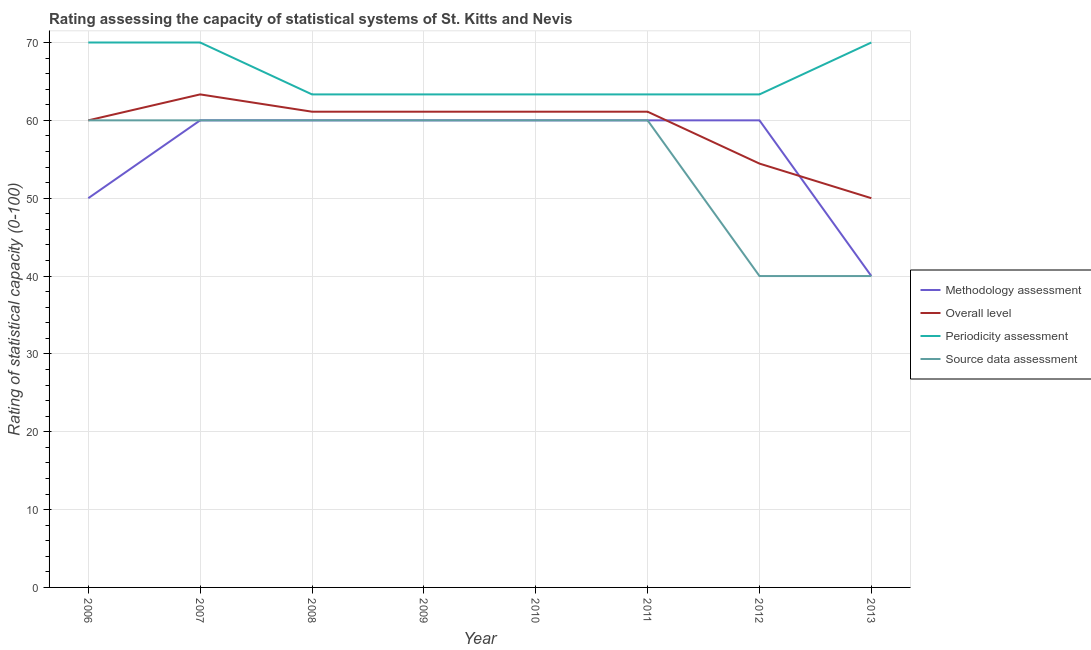Does the line corresponding to methodology assessment rating intersect with the line corresponding to periodicity assessment rating?
Offer a very short reply. No. What is the periodicity assessment rating in 2008?
Offer a terse response. 63.33. Across all years, what is the maximum source data assessment rating?
Your response must be concise. 60. Across all years, what is the minimum periodicity assessment rating?
Your response must be concise. 63.33. What is the total periodicity assessment rating in the graph?
Provide a short and direct response. 526.67. What is the difference between the periodicity assessment rating in 2010 and that in 2013?
Give a very brief answer. -6.67. What is the difference between the source data assessment rating in 2009 and the overall level rating in 2010?
Provide a short and direct response. -1.11. What is the average periodicity assessment rating per year?
Offer a very short reply. 65.83. In the year 2011, what is the difference between the source data assessment rating and overall level rating?
Give a very brief answer. -1.11. What is the ratio of the periodicity assessment rating in 2007 to that in 2011?
Your answer should be compact. 1.11. Is the overall level rating in 2010 less than that in 2011?
Provide a short and direct response. No. Is the difference between the overall level rating in 2012 and 2013 greater than the difference between the source data assessment rating in 2012 and 2013?
Your response must be concise. Yes. What is the difference between the highest and the second highest overall level rating?
Offer a very short reply. 2.22. What is the difference between the highest and the lowest methodology assessment rating?
Your answer should be compact. 20. In how many years, is the source data assessment rating greater than the average source data assessment rating taken over all years?
Provide a short and direct response. 6. Is it the case that in every year, the sum of the methodology assessment rating and source data assessment rating is greater than the sum of periodicity assessment rating and overall level rating?
Ensure brevity in your answer.  No. Does the periodicity assessment rating monotonically increase over the years?
Offer a very short reply. No. Is the methodology assessment rating strictly less than the periodicity assessment rating over the years?
Offer a very short reply. Yes. What is the difference between two consecutive major ticks on the Y-axis?
Offer a terse response. 10. Are the values on the major ticks of Y-axis written in scientific E-notation?
Ensure brevity in your answer.  No. Does the graph contain grids?
Provide a short and direct response. Yes. Where does the legend appear in the graph?
Offer a very short reply. Center right. How many legend labels are there?
Make the answer very short. 4. How are the legend labels stacked?
Your answer should be compact. Vertical. What is the title of the graph?
Provide a short and direct response. Rating assessing the capacity of statistical systems of St. Kitts and Nevis. What is the label or title of the X-axis?
Your answer should be very brief. Year. What is the label or title of the Y-axis?
Your response must be concise. Rating of statistical capacity (0-100). What is the Rating of statistical capacity (0-100) of Overall level in 2007?
Your response must be concise. 63.33. What is the Rating of statistical capacity (0-100) in Source data assessment in 2007?
Offer a very short reply. 60. What is the Rating of statistical capacity (0-100) in Methodology assessment in 2008?
Keep it short and to the point. 60. What is the Rating of statistical capacity (0-100) of Overall level in 2008?
Ensure brevity in your answer.  61.11. What is the Rating of statistical capacity (0-100) of Periodicity assessment in 2008?
Make the answer very short. 63.33. What is the Rating of statistical capacity (0-100) in Source data assessment in 2008?
Ensure brevity in your answer.  60. What is the Rating of statistical capacity (0-100) in Overall level in 2009?
Keep it short and to the point. 61.11. What is the Rating of statistical capacity (0-100) in Periodicity assessment in 2009?
Provide a short and direct response. 63.33. What is the Rating of statistical capacity (0-100) in Overall level in 2010?
Offer a very short reply. 61.11. What is the Rating of statistical capacity (0-100) of Periodicity assessment in 2010?
Provide a succinct answer. 63.33. What is the Rating of statistical capacity (0-100) in Source data assessment in 2010?
Provide a short and direct response. 60. What is the Rating of statistical capacity (0-100) of Overall level in 2011?
Ensure brevity in your answer.  61.11. What is the Rating of statistical capacity (0-100) of Periodicity assessment in 2011?
Offer a terse response. 63.33. What is the Rating of statistical capacity (0-100) in Methodology assessment in 2012?
Your response must be concise. 60. What is the Rating of statistical capacity (0-100) in Overall level in 2012?
Your answer should be compact. 54.44. What is the Rating of statistical capacity (0-100) in Periodicity assessment in 2012?
Give a very brief answer. 63.33. What is the Rating of statistical capacity (0-100) of Source data assessment in 2013?
Ensure brevity in your answer.  40. Across all years, what is the maximum Rating of statistical capacity (0-100) of Methodology assessment?
Make the answer very short. 60. Across all years, what is the maximum Rating of statistical capacity (0-100) in Overall level?
Your response must be concise. 63.33. Across all years, what is the minimum Rating of statistical capacity (0-100) in Methodology assessment?
Provide a short and direct response. 40. Across all years, what is the minimum Rating of statistical capacity (0-100) of Periodicity assessment?
Provide a succinct answer. 63.33. Across all years, what is the minimum Rating of statistical capacity (0-100) in Source data assessment?
Provide a succinct answer. 40. What is the total Rating of statistical capacity (0-100) of Methodology assessment in the graph?
Provide a short and direct response. 450. What is the total Rating of statistical capacity (0-100) in Overall level in the graph?
Keep it short and to the point. 472.22. What is the total Rating of statistical capacity (0-100) of Periodicity assessment in the graph?
Offer a very short reply. 526.67. What is the total Rating of statistical capacity (0-100) of Source data assessment in the graph?
Provide a short and direct response. 440. What is the difference between the Rating of statistical capacity (0-100) in Overall level in 2006 and that in 2007?
Provide a short and direct response. -3.33. What is the difference between the Rating of statistical capacity (0-100) of Source data assessment in 2006 and that in 2007?
Provide a short and direct response. 0. What is the difference between the Rating of statistical capacity (0-100) in Methodology assessment in 2006 and that in 2008?
Provide a short and direct response. -10. What is the difference between the Rating of statistical capacity (0-100) of Overall level in 2006 and that in 2008?
Keep it short and to the point. -1.11. What is the difference between the Rating of statistical capacity (0-100) in Periodicity assessment in 2006 and that in 2008?
Keep it short and to the point. 6.67. What is the difference between the Rating of statistical capacity (0-100) in Overall level in 2006 and that in 2009?
Ensure brevity in your answer.  -1.11. What is the difference between the Rating of statistical capacity (0-100) of Methodology assessment in 2006 and that in 2010?
Provide a short and direct response. -10. What is the difference between the Rating of statistical capacity (0-100) of Overall level in 2006 and that in 2010?
Your answer should be compact. -1.11. What is the difference between the Rating of statistical capacity (0-100) in Periodicity assessment in 2006 and that in 2010?
Provide a short and direct response. 6.67. What is the difference between the Rating of statistical capacity (0-100) in Source data assessment in 2006 and that in 2010?
Give a very brief answer. 0. What is the difference between the Rating of statistical capacity (0-100) of Methodology assessment in 2006 and that in 2011?
Make the answer very short. -10. What is the difference between the Rating of statistical capacity (0-100) of Overall level in 2006 and that in 2011?
Your answer should be compact. -1.11. What is the difference between the Rating of statistical capacity (0-100) of Periodicity assessment in 2006 and that in 2011?
Keep it short and to the point. 6.67. What is the difference between the Rating of statistical capacity (0-100) in Source data assessment in 2006 and that in 2011?
Your answer should be compact. 0. What is the difference between the Rating of statistical capacity (0-100) of Methodology assessment in 2006 and that in 2012?
Your response must be concise. -10. What is the difference between the Rating of statistical capacity (0-100) in Overall level in 2006 and that in 2012?
Offer a very short reply. 5.56. What is the difference between the Rating of statistical capacity (0-100) of Periodicity assessment in 2006 and that in 2012?
Your answer should be compact. 6.67. What is the difference between the Rating of statistical capacity (0-100) of Overall level in 2006 and that in 2013?
Make the answer very short. 10. What is the difference between the Rating of statistical capacity (0-100) of Source data assessment in 2006 and that in 2013?
Make the answer very short. 20. What is the difference between the Rating of statistical capacity (0-100) in Overall level in 2007 and that in 2008?
Offer a very short reply. 2.22. What is the difference between the Rating of statistical capacity (0-100) in Periodicity assessment in 2007 and that in 2008?
Your answer should be very brief. 6.67. What is the difference between the Rating of statistical capacity (0-100) of Source data assessment in 2007 and that in 2008?
Ensure brevity in your answer.  0. What is the difference between the Rating of statistical capacity (0-100) of Methodology assessment in 2007 and that in 2009?
Your answer should be compact. 0. What is the difference between the Rating of statistical capacity (0-100) of Overall level in 2007 and that in 2009?
Keep it short and to the point. 2.22. What is the difference between the Rating of statistical capacity (0-100) of Source data assessment in 2007 and that in 2009?
Your answer should be compact. 0. What is the difference between the Rating of statistical capacity (0-100) in Overall level in 2007 and that in 2010?
Your answer should be compact. 2.22. What is the difference between the Rating of statistical capacity (0-100) of Periodicity assessment in 2007 and that in 2010?
Offer a very short reply. 6.67. What is the difference between the Rating of statistical capacity (0-100) of Source data assessment in 2007 and that in 2010?
Your answer should be very brief. 0. What is the difference between the Rating of statistical capacity (0-100) of Overall level in 2007 and that in 2011?
Keep it short and to the point. 2.22. What is the difference between the Rating of statistical capacity (0-100) in Periodicity assessment in 2007 and that in 2011?
Offer a very short reply. 6.67. What is the difference between the Rating of statistical capacity (0-100) of Overall level in 2007 and that in 2012?
Offer a terse response. 8.89. What is the difference between the Rating of statistical capacity (0-100) in Methodology assessment in 2007 and that in 2013?
Provide a succinct answer. 20. What is the difference between the Rating of statistical capacity (0-100) of Overall level in 2007 and that in 2013?
Offer a very short reply. 13.33. What is the difference between the Rating of statistical capacity (0-100) in Periodicity assessment in 2007 and that in 2013?
Provide a short and direct response. 0. What is the difference between the Rating of statistical capacity (0-100) of Source data assessment in 2007 and that in 2013?
Make the answer very short. 20. What is the difference between the Rating of statistical capacity (0-100) in Methodology assessment in 2008 and that in 2009?
Your answer should be compact. 0. What is the difference between the Rating of statistical capacity (0-100) of Overall level in 2008 and that in 2009?
Make the answer very short. 0. What is the difference between the Rating of statistical capacity (0-100) of Source data assessment in 2008 and that in 2009?
Your answer should be very brief. 0. What is the difference between the Rating of statistical capacity (0-100) of Methodology assessment in 2008 and that in 2010?
Your answer should be very brief. 0. What is the difference between the Rating of statistical capacity (0-100) in Overall level in 2008 and that in 2010?
Your answer should be compact. 0. What is the difference between the Rating of statistical capacity (0-100) of Periodicity assessment in 2008 and that in 2010?
Provide a succinct answer. 0. What is the difference between the Rating of statistical capacity (0-100) in Overall level in 2008 and that in 2011?
Make the answer very short. 0. What is the difference between the Rating of statistical capacity (0-100) in Periodicity assessment in 2008 and that in 2011?
Give a very brief answer. 0. What is the difference between the Rating of statistical capacity (0-100) in Methodology assessment in 2008 and that in 2012?
Give a very brief answer. 0. What is the difference between the Rating of statistical capacity (0-100) of Overall level in 2008 and that in 2012?
Offer a very short reply. 6.67. What is the difference between the Rating of statistical capacity (0-100) in Periodicity assessment in 2008 and that in 2012?
Your answer should be compact. 0. What is the difference between the Rating of statistical capacity (0-100) of Source data assessment in 2008 and that in 2012?
Your answer should be very brief. 20. What is the difference between the Rating of statistical capacity (0-100) of Overall level in 2008 and that in 2013?
Your answer should be very brief. 11.11. What is the difference between the Rating of statistical capacity (0-100) in Periodicity assessment in 2008 and that in 2013?
Provide a succinct answer. -6.67. What is the difference between the Rating of statistical capacity (0-100) of Methodology assessment in 2009 and that in 2010?
Provide a succinct answer. 0. What is the difference between the Rating of statistical capacity (0-100) of Overall level in 2009 and that in 2010?
Keep it short and to the point. 0. What is the difference between the Rating of statistical capacity (0-100) of Periodicity assessment in 2009 and that in 2010?
Offer a terse response. 0. What is the difference between the Rating of statistical capacity (0-100) in Source data assessment in 2009 and that in 2010?
Ensure brevity in your answer.  0. What is the difference between the Rating of statistical capacity (0-100) of Methodology assessment in 2009 and that in 2011?
Give a very brief answer. 0. What is the difference between the Rating of statistical capacity (0-100) of Overall level in 2009 and that in 2011?
Offer a very short reply. 0. What is the difference between the Rating of statistical capacity (0-100) in Methodology assessment in 2009 and that in 2013?
Offer a very short reply. 20. What is the difference between the Rating of statistical capacity (0-100) of Overall level in 2009 and that in 2013?
Offer a very short reply. 11.11. What is the difference between the Rating of statistical capacity (0-100) of Periodicity assessment in 2009 and that in 2013?
Make the answer very short. -6.67. What is the difference between the Rating of statistical capacity (0-100) in Source data assessment in 2010 and that in 2011?
Keep it short and to the point. 0. What is the difference between the Rating of statistical capacity (0-100) of Overall level in 2010 and that in 2013?
Provide a short and direct response. 11.11. What is the difference between the Rating of statistical capacity (0-100) in Periodicity assessment in 2010 and that in 2013?
Keep it short and to the point. -6.67. What is the difference between the Rating of statistical capacity (0-100) in Source data assessment in 2010 and that in 2013?
Your response must be concise. 20. What is the difference between the Rating of statistical capacity (0-100) of Overall level in 2011 and that in 2012?
Give a very brief answer. 6.67. What is the difference between the Rating of statistical capacity (0-100) of Periodicity assessment in 2011 and that in 2012?
Make the answer very short. 0. What is the difference between the Rating of statistical capacity (0-100) of Methodology assessment in 2011 and that in 2013?
Your answer should be very brief. 20. What is the difference between the Rating of statistical capacity (0-100) of Overall level in 2011 and that in 2013?
Provide a succinct answer. 11.11. What is the difference between the Rating of statistical capacity (0-100) in Periodicity assessment in 2011 and that in 2013?
Your answer should be compact. -6.67. What is the difference between the Rating of statistical capacity (0-100) in Source data assessment in 2011 and that in 2013?
Your answer should be compact. 20. What is the difference between the Rating of statistical capacity (0-100) of Overall level in 2012 and that in 2013?
Keep it short and to the point. 4.44. What is the difference between the Rating of statistical capacity (0-100) in Periodicity assessment in 2012 and that in 2013?
Offer a very short reply. -6.67. What is the difference between the Rating of statistical capacity (0-100) of Methodology assessment in 2006 and the Rating of statistical capacity (0-100) of Overall level in 2007?
Your response must be concise. -13.33. What is the difference between the Rating of statistical capacity (0-100) of Methodology assessment in 2006 and the Rating of statistical capacity (0-100) of Periodicity assessment in 2007?
Make the answer very short. -20. What is the difference between the Rating of statistical capacity (0-100) of Methodology assessment in 2006 and the Rating of statistical capacity (0-100) of Source data assessment in 2007?
Offer a very short reply. -10. What is the difference between the Rating of statistical capacity (0-100) in Methodology assessment in 2006 and the Rating of statistical capacity (0-100) in Overall level in 2008?
Offer a terse response. -11.11. What is the difference between the Rating of statistical capacity (0-100) of Methodology assessment in 2006 and the Rating of statistical capacity (0-100) of Periodicity assessment in 2008?
Give a very brief answer. -13.33. What is the difference between the Rating of statistical capacity (0-100) in Methodology assessment in 2006 and the Rating of statistical capacity (0-100) in Source data assessment in 2008?
Give a very brief answer. -10. What is the difference between the Rating of statistical capacity (0-100) in Overall level in 2006 and the Rating of statistical capacity (0-100) in Source data assessment in 2008?
Offer a very short reply. 0. What is the difference between the Rating of statistical capacity (0-100) of Periodicity assessment in 2006 and the Rating of statistical capacity (0-100) of Source data assessment in 2008?
Ensure brevity in your answer.  10. What is the difference between the Rating of statistical capacity (0-100) of Methodology assessment in 2006 and the Rating of statistical capacity (0-100) of Overall level in 2009?
Your answer should be compact. -11.11. What is the difference between the Rating of statistical capacity (0-100) of Methodology assessment in 2006 and the Rating of statistical capacity (0-100) of Periodicity assessment in 2009?
Provide a succinct answer. -13.33. What is the difference between the Rating of statistical capacity (0-100) in Periodicity assessment in 2006 and the Rating of statistical capacity (0-100) in Source data assessment in 2009?
Offer a terse response. 10. What is the difference between the Rating of statistical capacity (0-100) in Methodology assessment in 2006 and the Rating of statistical capacity (0-100) in Overall level in 2010?
Ensure brevity in your answer.  -11.11. What is the difference between the Rating of statistical capacity (0-100) of Methodology assessment in 2006 and the Rating of statistical capacity (0-100) of Periodicity assessment in 2010?
Ensure brevity in your answer.  -13.33. What is the difference between the Rating of statistical capacity (0-100) in Methodology assessment in 2006 and the Rating of statistical capacity (0-100) in Source data assessment in 2010?
Provide a short and direct response. -10. What is the difference between the Rating of statistical capacity (0-100) in Overall level in 2006 and the Rating of statistical capacity (0-100) in Periodicity assessment in 2010?
Ensure brevity in your answer.  -3.33. What is the difference between the Rating of statistical capacity (0-100) in Overall level in 2006 and the Rating of statistical capacity (0-100) in Source data assessment in 2010?
Provide a succinct answer. 0. What is the difference between the Rating of statistical capacity (0-100) in Periodicity assessment in 2006 and the Rating of statistical capacity (0-100) in Source data assessment in 2010?
Ensure brevity in your answer.  10. What is the difference between the Rating of statistical capacity (0-100) of Methodology assessment in 2006 and the Rating of statistical capacity (0-100) of Overall level in 2011?
Your answer should be compact. -11.11. What is the difference between the Rating of statistical capacity (0-100) in Methodology assessment in 2006 and the Rating of statistical capacity (0-100) in Periodicity assessment in 2011?
Provide a short and direct response. -13.33. What is the difference between the Rating of statistical capacity (0-100) in Methodology assessment in 2006 and the Rating of statistical capacity (0-100) in Source data assessment in 2011?
Offer a terse response. -10. What is the difference between the Rating of statistical capacity (0-100) in Overall level in 2006 and the Rating of statistical capacity (0-100) in Periodicity assessment in 2011?
Give a very brief answer. -3.33. What is the difference between the Rating of statistical capacity (0-100) in Periodicity assessment in 2006 and the Rating of statistical capacity (0-100) in Source data assessment in 2011?
Ensure brevity in your answer.  10. What is the difference between the Rating of statistical capacity (0-100) in Methodology assessment in 2006 and the Rating of statistical capacity (0-100) in Overall level in 2012?
Your response must be concise. -4.44. What is the difference between the Rating of statistical capacity (0-100) in Methodology assessment in 2006 and the Rating of statistical capacity (0-100) in Periodicity assessment in 2012?
Your answer should be compact. -13.33. What is the difference between the Rating of statistical capacity (0-100) of Overall level in 2006 and the Rating of statistical capacity (0-100) of Source data assessment in 2012?
Offer a terse response. 20. What is the difference between the Rating of statistical capacity (0-100) of Methodology assessment in 2006 and the Rating of statistical capacity (0-100) of Overall level in 2013?
Keep it short and to the point. 0. What is the difference between the Rating of statistical capacity (0-100) in Methodology assessment in 2006 and the Rating of statistical capacity (0-100) in Periodicity assessment in 2013?
Provide a short and direct response. -20. What is the difference between the Rating of statistical capacity (0-100) in Methodology assessment in 2006 and the Rating of statistical capacity (0-100) in Source data assessment in 2013?
Keep it short and to the point. 10. What is the difference between the Rating of statistical capacity (0-100) in Overall level in 2006 and the Rating of statistical capacity (0-100) in Source data assessment in 2013?
Make the answer very short. 20. What is the difference between the Rating of statistical capacity (0-100) in Methodology assessment in 2007 and the Rating of statistical capacity (0-100) in Overall level in 2008?
Keep it short and to the point. -1.11. What is the difference between the Rating of statistical capacity (0-100) in Overall level in 2007 and the Rating of statistical capacity (0-100) in Periodicity assessment in 2008?
Offer a terse response. 0. What is the difference between the Rating of statistical capacity (0-100) in Periodicity assessment in 2007 and the Rating of statistical capacity (0-100) in Source data assessment in 2008?
Your answer should be very brief. 10. What is the difference between the Rating of statistical capacity (0-100) of Methodology assessment in 2007 and the Rating of statistical capacity (0-100) of Overall level in 2009?
Offer a very short reply. -1.11. What is the difference between the Rating of statistical capacity (0-100) in Methodology assessment in 2007 and the Rating of statistical capacity (0-100) in Periodicity assessment in 2009?
Provide a short and direct response. -3.33. What is the difference between the Rating of statistical capacity (0-100) of Methodology assessment in 2007 and the Rating of statistical capacity (0-100) of Source data assessment in 2009?
Offer a very short reply. 0. What is the difference between the Rating of statistical capacity (0-100) of Methodology assessment in 2007 and the Rating of statistical capacity (0-100) of Overall level in 2010?
Offer a terse response. -1.11. What is the difference between the Rating of statistical capacity (0-100) of Methodology assessment in 2007 and the Rating of statistical capacity (0-100) of Overall level in 2011?
Offer a terse response. -1.11. What is the difference between the Rating of statistical capacity (0-100) of Methodology assessment in 2007 and the Rating of statistical capacity (0-100) of Periodicity assessment in 2011?
Keep it short and to the point. -3.33. What is the difference between the Rating of statistical capacity (0-100) of Methodology assessment in 2007 and the Rating of statistical capacity (0-100) of Source data assessment in 2011?
Offer a very short reply. 0. What is the difference between the Rating of statistical capacity (0-100) in Overall level in 2007 and the Rating of statistical capacity (0-100) in Periodicity assessment in 2011?
Provide a succinct answer. 0. What is the difference between the Rating of statistical capacity (0-100) in Methodology assessment in 2007 and the Rating of statistical capacity (0-100) in Overall level in 2012?
Offer a terse response. 5.56. What is the difference between the Rating of statistical capacity (0-100) in Methodology assessment in 2007 and the Rating of statistical capacity (0-100) in Periodicity assessment in 2012?
Provide a succinct answer. -3.33. What is the difference between the Rating of statistical capacity (0-100) of Methodology assessment in 2007 and the Rating of statistical capacity (0-100) of Source data assessment in 2012?
Give a very brief answer. 20. What is the difference between the Rating of statistical capacity (0-100) of Overall level in 2007 and the Rating of statistical capacity (0-100) of Source data assessment in 2012?
Your response must be concise. 23.33. What is the difference between the Rating of statistical capacity (0-100) of Methodology assessment in 2007 and the Rating of statistical capacity (0-100) of Periodicity assessment in 2013?
Provide a short and direct response. -10. What is the difference between the Rating of statistical capacity (0-100) of Methodology assessment in 2007 and the Rating of statistical capacity (0-100) of Source data assessment in 2013?
Make the answer very short. 20. What is the difference between the Rating of statistical capacity (0-100) in Overall level in 2007 and the Rating of statistical capacity (0-100) in Periodicity assessment in 2013?
Provide a short and direct response. -6.67. What is the difference between the Rating of statistical capacity (0-100) in Overall level in 2007 and the Rating of statistical capacity (0-100) in Source data assessment in 2013?
Offer a terse response. 23.33. What is the difference between the Rating of statistical capacity (0-100) of Methodology assessment in 2008 and the Rating of statistical capacity (0-100) of Overall level in 2009?
Offer a very short reply. -1.11. What is the difference between the Rating of statistical capacity (0-100) of Overall level in 2008 and the Rating of statistical capacity (0-100) of Periodicity assessment in 2009?
Provide a short and direct response. -2.22. What is the difference between the Rating of statistical capacity (0-100) in Periodicity assessment in 2008 and the Rating of statistical capacity (0-100) in Source data assessment in 2009?
Offer a very short reply. 3.33. What is the difference between the Rating of statistical capacity (0-100) in Methodology assessment in 2008 and the Rating of statistical capacity (0-100) in Overall level in 2010?
Keep it short and to the point. -1.11. What is the difference between the Rating of statistical capacity (0-100) of Overall level in 2008 and the Rating of statistical capacity (0-100) of Periodicity assessment in 2010?
Your answer should be very brief. -2.22. What is the difference between the Rating of statistical capacity (0-100) in Overall level in 2008 and the Rating of statistical capacity (0-100) in Source data assessment in 2010?
Provide a succinct answer. 1.11. What is the difference between the Rating of statistical capacity (0-100) of Periodicity assessment in 2008 and the Rating of statistical capacity (0-100) of Source data assessment in 2010?
Your answer should be very brief. 3.33. What is the difference between the Rating of statistical capacity (0-100) in Methodology assessment in 2008 and the Rating of statistical capacity (0-100) in Overall level in 2011?
Provide a short and direct response. -1.11. What is the difference between the Rating of statistical capacity (0-100) of Methodology assessment in 2008 and the Rating of statistical capacity (0-100) of Periodicity assessment in 2011?
Offer a terse response. -3.33. What is the difference between the Rating of statistical capacity (0-100) of Overall level in 2008 and the Rating of statistical capacity (0-100) of Periodicity assessment in 2011?
Offer a terse response. -2.22. What is the difference between the Rating of statistical capacity (0-100) in Overall level in 2008 and the Rating of statistical capacity (0-100) in Source data assessment in 2011?
Provide a short and direct response. 1.11. What is the difference between the Rating of statistical capacity (0-100) of Methodology assessment in 2008 and the Rating of statistical capacity (0-100) of Overall level in 2012?
Provide a short and direct response. 5.56. What is the difference between the Rating of statistical capacity (0-100) in Methodology assessment in 2008 and the Rating of statistical capacity (0-100) in Source data assessment in 2012?
Your response must be concise. 20. What is the difference between the Rating of statistical capacity (0-100) of Overall level in 2008 and the Rating of statistical capacity (0-100) of Periodicity assessment in 2012?
Provide a succinct answer. -2.22. What is the difference between the Rating of statistical capacity (0-100) in Overall level in 2008 and the Rating of statistical capacity (0-100) in Source data assessment in 2012?
Offer a terse response. 21.11. What is the difference between the Rating of statistical capacity (0-100) of Periodicity assessment in 2008 and the Rating of statistical capacity (0-100) of Source data assessment in 2012?
Provide a short and direct response. 23.33. What is the difference between the Rating of statistical capacity (0-100) in Overall level in 2008 and the Rating of statistical capacity (0-100) in Periodicity assessment in 2013?
Provide a succinct answer. -8.89. What is the difference between the Rating of statistical capacity (0-100) of Overall level in 2008 and the Rating of statistical capacity (0-100) of Source data assessment in 2013?
Keep it short and to the point. 21.11. What is the difference between the Rating of statistical capacity (0-100) in Periodicity assessment in 2008 and the Rating of statistical capacity (0-100) in Source data assessment in 2013?
Offer a very short reply. 23.33. What is the difference between the Rating of statistical capacity (0-100) in Methodology assessment in 2009 and the Rating of statistical capacity (0-100) in Overall level in 2010?
Ensure brevity in your answer.  -1.11. What is the difference between the Rating of statistical capacity (0-100) in Overall level in 2009 and the Rating of statistical capacity (0-100) in Periodicity assessment in 2010?
Keep it short and to the point. -2.22. What is the difference between the Rating of statistical capacity (0-100) in Overall level in 2009 and the Rating of statistical capacity (0-100) in Source data assessment in 2010?
Your response must be concise. 1.11. What is the difference between the Rating of statistical capacity (0-100) in Periodicity assessment in 2009 and the Rating of statistical capacity (0-100) in Source data assessment in 2010?
Offer a very short reply. 3.33. What is the difference between the Rating of statistical capacity (0-100) of Methodology assessment in 2009 and the Rating of statistical capacity (0-100) of Overall level in 2011?
Ensure brevity in your answer.  -1.11. What is the difference between the Rating of statistical capacity (0-100) in Overall level in 2009 and the Rating of statistical capacity (0-100) in Periodicity assessment in 2011?
Keep it short and to the point. -2.22. What is the difference between the Rating of statistical capacity (0-100) of Methodology assessment in 2009 and the Rating of statistical capacity (0-100) of Overall level in 2012?
Offer a terse response. 5.56. What is the difference between the Rating of statistical capacity (0-100) in Methodology assessment in 2009 and the Rating of statistical capacity (0-100) in Periodicity assessment in 2012?
Ensure brevity in your answer.  -3.33. What is the difference between the Rating of statistical capacity (0-100) in Methodology assessment in 2009 and the Rating of statistical capacity (0-100) in Source data assessment in 2012?
Your answer should be compact. 20. What is the difference between the Rating of statistical capacity (0-100) of Overall level in 2009 and the Rating of statistical capacity (0-100) of Periodicity assessment in 2012?
Offer a terse response. -2.22. What is the difference between the Rating of statistical capacity (0-100) of Overall level in 2009 and the Rating of statistical capacity (0-100) of Source data assessment in 2012?
Keep it short and to the point. 21.11. What is the difference between the Rating of statistical capacity (0-100) in Periodicity assessment in 2009 and the Rating of statistical capacity (0-100) in Source data assessment in 2012?
Offer a very short reply. 23.33. What is the difference between the Rating of statistical capacity (0-100) of Methodology assessment in 2009 and the Rating of statistical capacity (0-100) of Overall level in 2013?
Your answer should be very brief. 10. What is the difference between the Rating of statistical capacity (0-100) in Methodology assessment in 2009 and the Rating of statistical capacity (0-100) in Source data assessment in 2013?
Make the answer very short. 20. What is the difference between the Rating of statistical capacity (0-100) in Overall level in 2009 and the Rating of statistical capacity (0-100) in Periodicity assessment in 2013?
Provide a succinct answer. -8.89. What is the difference between the Rating of statistical capacity (0-100) of Overall level in 2009 and the Rating of statistical capacity (0-100) of Source data assessment in 2013?
Provide a short and direct response. 21.11. What is the difference between the Rating of statistical capacity (0-100) in Periodicity assessment in 2009 and the Rating of statistical capacity (0-100) in Source data assessment in 2013?
Make the answer very short. 23.33. What is the difference between the Rating of statistical capacity (0-100) of Methodology assessment in 2010 and the Rating of statistical capacity (0-100) of Overall level in 2011?
Offer a terse response. -1.11. What is the difference between the Rating of statistical capacity (0-100) of Methodology assessment in 2010 and the Rating of statistical capacity (0-100) of Periodicity assessment in 2011?
Provide a succinct answer. -3.33. What is the difference between the Rating of statistical capacity (0-100) in Overall level in 2010 and the Rating of statistical capacity (0-100) in Periodicity assessment in 2011?
Make the answer very short. -2.22. What is the difference between the Rating of statistical capacity (0-100) of Periodicity assessment in 2010 and the Rating of statistical capacity (0-100) of Source data assessment in 2011?
Offer a very short reply. 3.33. What is the difference between the Rating of statistical capacity (0-100) in Methodology assessment in 2010 and the Rating of statistical capacity (0-100) in Overall level in 2012?
Your answer should be very brief. 5.56. What is the difference between the Rating of statistical capacity (0-100) of Methodology assessment in 2010 and the Rating of statistical capacity (0-100) of Source data assessment in 2012?
Offer a terse response. 20. What is the difference between the Rating of statistical capacity (0-100) of Overall level in 2010 and the Rating of statistical capacity (0-100) of Periodicity assessment in 2012?
Provide a short and direct response. -2.22. What is the difference between the Rating of statistical capacity (0-100) in Overall level in 2010 and the Rating of statistical capacity (0-100) in Source data assessment in 2012?
Your answer should be very brief. 21.11. What is the difference between the Rating of statistical capacity (0-100) of Periodicity assessment in 2010 and the Rating of statistical capacity (0-100) of Source data assessment in 2012?
Keep it short and to the point. 23.33. What is the difference between the Rating of statistical capacity (0-100) of Methodology assessment in 2010 and the Rating of statistical capacity (0-100) of Periodicity assessment in 2013?
Provide a short and direct response. -10. What is the difference between the Rating of statistical capacity (0-100) in Overall level in 2010 and the Rating of statistical capacity (0-100) in Periodicity assessment in 2013?
Your answer should be very brief. -8.89. What is the difference between the Rating of statistical capacity (0-100) of Overall level in 2010 and the Rating of statistical capacity (0-100) of Source data assessment in 2013?
Offer a very short reply. 21.11. What is the difference between the Rating of statistical capacity (0-100) in Periodicity assessment in 2010 and the Rating of statistical capacity (0-100) in Source data assessment in 2013?
Ensure brevity in your answer.  23.33. What is the difference between the Rating of statistical capacity (0-100) in Methodology assessment in 2011 and the Rating of statistical capacity (0-100) in Overall level in 2012?
Your answer should be compact. 5.56. What is the difference between the Rating of statistical capacity (0-100) of Methodology assessment in 2011 and the Rating of statistical capacity (0-100) of Periodicity assessment in 2012?
Ensure brevity in your answer.  -3.33. What is the difference between the Rating of statistical capacity (0-100) of Overall level in 2011 and the Rating of statistical capacity (0-100) of Periodicity assessment in 2012?
Offer a terse response. -2.22. What is the difference between the Rating of statistical capacity (0-100) of Overall level in 2011 and the Rating of statistical capacity (0-100) of Source data assessment in 2012?
Your response must be concise. 21.11. What is the difference between the Rating of statistical capacity (0-100) of Periodicity assessment in 2011 and the Rating of statistical capacity (0-100) of Source data assessment in 2012?
Keep it short and to the point. 23.33. What is the difference between the Rating of statistical capacity (0-100) of Overall level in 2011 and the Rating of statistical capacity (0-100) of Periodicity assessment in 2013?
Your answer should be very brief. -8.89. What is the difference between the Rating of statistical capacity (0-100) of Overall level in 2011 and the Rating of statistical capacity (0-100) of Source data assessment in 2013?
Give a very brief answer. 21.11. What is the difference between the Rating of statistical capacity (0-100) of Periodicity assessment in 2011 and the Rating of statistical capacity (0-100) of Source data assessment in 2013?
Offer a terse response. 23.33. What is the difference between the Rating of statistical capacity (0-100) of Methodology assessment in 2012 and the Rating of statistical capacity (0-100) of Overall level in 2013?
Offer a terse response. 10. What is the difference between the Rating of statistical capacity (0-100) of Methodology assessment in 2012 and the Rating of statistical capacity (0-100) of Source data assessment in 2013?
Keep it short and to the point. 20. What is the difference between the Rating of statistical capacity (0-100) in Overall level in 2012 and the Rating of statistical capacity (0-100) in Periodicity assessment in 2013?
Your response must be concise. -15.56. What is the difference between the Rating of statistical capacity (0-100) of Overall level in 2012 and the Rating of statistical capacity (0-100) of Source data assessment in 2013?
Keep it short and to the point. 14.44. What is the difference between the Rating of statistical capacity (0-100) of Periodicity assessment in 2012 and the Rating of statistical capacity (0-100) of Source data assessment in 2013?
Make the answer very short. 23.33. What is the average Rating of statistical capacity (0-100) in Methodology assessment per year?
Your answer should be very brief. 56.25. What is the average Rating of statistical capacity (0-100) in Overall level per year?
Offer a very short reply. 59.03. What is the average Rating of statistical capacity (0-100) in Periodicity assessment per year?
Make the answer very short. 65.83. What is the average Rating of statistical capacity (0-100) in Source data assessment per year?
Make the answer very short. 55. In the year 2006, what is the difference between the Rating of statistical capacity (0-100) in Methodology assessment and Rating of statistical capacity (0-100) in Overall level?
Provide a short and direct response. -10. In the year 2006, what is the difference between the Rating of statistical capacity (0-100) in Overall level and Rating of statistical capacity (0-100) in Periodicity assessment?
Ensure brevity in your answer.  -10. In the year 2006, what is the difference between the Rating of statistical capacity (0-100) in Overall level and Rating of statistical capacity (0-100) in Source data assessment?
Provide a short and direct response. 0. In the year 2007, what is the difference between the Rating of statistical capacity (0-100) of Methodology assessment and Rating of statistical capacity (0-100) of Overall level?
Make the answer very short. -3.33. In the year 2007, what is the difference between the Rating of statistical capacity (0-100) of Overall level and Rating of statistical capacity (0-100) of Periodicity assessment?
Make the answer very short. -6.67. In the year 2008, what is the difference between the Rating of statistical capacity (0-100) in Methodology assessment and Rating of statistical capacity (0-100) in Overall level?
Keep it short and to the point. -1.11. In the year 2008, what is the difference between the Rating of statistical capacity (0-100) of Overall level and Rating of statistical capacity (0-100) of Periodicity assessment?
Offer a terse response. -2.22. In the year 2008, what is the difference between the Rating of statistical capacity (0-100) in Periodicity assessment and Rating of statistical capacity (0-100) in Source data assessment?
Your response must be concise. 3.33. In the year 2009, what is the difference between the Rating of statistical capacity (0-100) in Methodology assessment and Rating of statistical capacity (0-100) in Overall level?
Offer a very short reply. -1.11. In the year 2009, what is the difference between the Rating of statistical capacity (0-100) of Methodology assessment and Rating of statistical capacity (0-100) of Periodicity assessment?
Ensure brevity in your answer.  -3.33. In the year 2009, what is the difference between the Rating of statistical capacity (0-100) of Methodology assessment and Rating of statistical capacity (0-100) of Source data assessment?
Give a very brief answer. 0. In the year 2009, what is the difference between the Rating of statistical capacity (0-100) of Overall level and Rating of statistical capacity (0-100) of Periodicity assessment?
Make the answer very short. -2.22. In the year 2009, what is the difference between the Rating of statistical capacity (0-100) in Overall level and Rating of statistical capacity (0-100) in Source data assessment?
Provide a succinct answer. 1.11. In the year 2009, what is the difference between the Rating of statistical capacity (0-100) of Periodicity assessment and Rating of statistical capacity (0-100) of Source data assessment?
Make the answer very short. 3.33. In the year 2010, what is the difference between the Rating of statistical capacity (0-100) of Methodology assessment and Rating of statistical capacity (0-100) of Overall level?
Your answer should be compact. -1.11. In the year 2010, what is the difference between the Rating of statistical capacity (0-100) in Overall level and Rating of statistical capacity (0-100) in Periodicity assessment?
Your answer should be compact. -2.22. In the year 2010, what is the difference between the Rating of statistical capacity (0-100) in Overall level and Rating of statistical capacity (0-100) in Source data assessment?
Keep it short and to the point. 1.11. In the year 2010, what is the difference between the Rating of statistical capacity (0-100) in Periodicity assessment and Rating of statistical capacity (0-100) in Source data assessment?
Your answer should be very brief. 3.33. In the year 2011, what is the difference between the Rating of statistical capacity (0-100) in Methodology assessment and Rating of statistical capacity (0-100) in Overall level?
Your answer should be compact. -1.11. In the year 2011, what is the difference between the Rating of statistical capacity (0-100) of Methodology assessment and Rating of statistical capacity (0-100) of Periodicity assessment?
Ensure brevity in your answer.  -3.33. In the year 2011, what is the difference between the Rating of statistical capacity (0-100) of Methodology assessment and Rating of statistical capacity (0-100) of Source data assessment?
Offer a very short reply. 0. In the year 2011, what is the difference between the Rating of statistical capacity (0-100) in Overall level and Rating of statistical capacity (0-100) in Periodicity assessment?
Your answer should be compact. -2.22. In the year 2011, what is the difference between the Rating of statistical capacity (0-100) in Overall level and Rating of statistical capacity (0-100) in Source data assessment?
Give a very brief answer. 1.11. In the year 2012, what is the difference between the Rating of statistical capacity (0-100) in Methodology assessment and Rating of statistical capacity (0-100) in Overall level?
Offer a terse response. 5.56. In the year 2012, what is the difference between the Rating of statistical capacity (0-100) of Methodology assessment and Rating of statistical capacity (0-100) of Periodicity assessment?
Provide a succinct answer. -3.33. In the year 2012, what is the difference between the Rating of statistical capacity (0-100) of Methodology assessment and Rating of statistical capacity (0-100) of Source data assessment?
Ensure brevity in your answer.  20. In the year 2012, what is the difference between the Rating of statistical capacity (0-100) of Overall level and Rating of statistical capacity (0-100) of Periodicity assessment?
Provide a succinct answer. -8.89. In the year 2012, what is the difference between the Rating of statistical capacity (0-100) in Overall level and Rating of statistical capacity (0-100) in Source data assessment?
Provide a succinct answer. 14.44. In the year 2012, what is the difference between the Rating of statistical capacity (0-100) of Periodicity assessment and Rating of statistical capacity (0-100) of Source data assessment?
Make the answer very short. 23.33. In the year 2013, what is the difference between the Rating of statistical capacity (0-100) of Overall level and Rating of statistical capacity (0-100) of Periodicity assessment?
Offer a terse response. -20. In the year 2013, what is the difference between the Rating of statistical capacity (0-100) of Overall level and Rating of statistical capacity (0-100) of Source data assessment?
Ensure brevity in your answer.  10. What is the ratio of the Rating of statistical capacity (0-100) in Overall level in 2006 to that in 2007?
Provide a short and direct response. 0.95. What is the ratio of the Rating of statistical capacity (0-100) in Source data assessment in 2006 to that in 2007?
Provide a succinct answer. 1. What is the ratio of the Rating of statistical capacity (0-100) of Overall level in 2006 to that in 2008?
Give a very brief answer. 0.98. What is the ratio of the Rating of statistical capacity (0-100) in Periodicity assessment in 2006 to that in 2008?
Provide a succinct answer. 1.11. What is the ratio of the Rating of statistical capacity (0-100) of Source data assessment in 2006 to that in 2008?
Offer a very short reply. 1. What is the ratio of the Rating of statistical capacity (0-100) of Overall level in 2006 to that in 2009?
Provide a short and direct response. 0.98. What is the ratio of the Rating of statistical capacity (0-100) in Periodicity assessment in 2006 to that in 2009?
Offer a very short reply. 1.11. What is the ratio of the Rating of statistical capacity (0-100) in Source data assessment in 2006 to that in 2009?
Offer a terse response. 1. What is the ratio of the Rating of statistical capacity (0-100) in Methodology assessment in 2006 to that in 2010?
Your answer should be very brief. 0.83. What is the ratio of the Rating of statistical capacity (0-100) in Overall level in 2006 to that in 2010?
Your answer should be very brief. 0.98. What is the ratio of the Rating of statistical capacity (0-100) in Periodicity assessment in 2006 to that in 2010?
Make the answer very short. 1.11. What is the ratio of the Rating of statistical capacity (0-100) of Methodology assessment in 2006 to that in 2011?
Give a very brief answer. 0.83. What is the ratio of the Rating of statistical capacity (0-100) in Overall level in 2006 to that in 2011?
Offer a very short reply. 0.98. What is the ratio of the Rating of statistical capacity (0-100) in Periodicity assessment in 2006 to that in 2011?
Your answer should be compact. 1.11. What is the ratio of the Rating of statistical capacity (0-100) of Source data assessment in 2006 to that in 2011?
Ensure brevity in your answer.  1. What is the ratio of the Rating of statistical capacity (0-100) in Overall level in 2006 to that in 2012?
Offer a terse response. 1.1. What is the ratio of the Rating of statistical capacity (0-100) of Periodicity assessment in 2006 to that in 2012?
Ensure brevity in your answer.  1.11. What is the ratio of the Rating of statistical capacity (0-100) of Overall level in 2007 to that in 2008?
Offer a very short reply. 1.04. What is the ratio of the Rating of statistical capacity (0-100) of Periodicity assessment in 2007 to that in 2008?
Your answer should be compact. 1.11. What is the ratio of the Rating of statistical capacity (0-100) of Source data assessment in 2007 to that in 2008?
Provide a succinct answer. 1. What is the ratio of the Rating of statistical capacity (0-100) of Methodology assessment in 2007 to that in 2009?
Your answer should be very brief. 1. What is the ratio of the Rating of statistical capacity (0-100) in Overall level in 2007 to that in 2009?
Provide a succinct answer. 1.04. What is the ratio of the Rating of statistical capacity (0-100) in Periodicity assessment in 2007 to that in 2009?
Ensure brevity in your answer.  1.11. What is the ratio of the Rating of statistical capacity (0-100) of Methodology assessment in 2007 to that in 2010?
Your response must be concise. 1. What is the ratio of the Rating of statistical capacity (0-100) in Overall level in 2007 to that in 2010?
Ensure brevity in your answer.  1.04. What is the ratio of the Rating of statistical capacity (0-100) of Periodicity assessment in 2007 to that in 2010?
Your answer should be compact. 1.11. What is the ratio of the Rating of statistical capacity (0-100) of Source data assessment in 2007 to that in 2010?
Offer a very short reply. 1. What is the ratio of the Rating of statistical capacity (0-100) in Methodology assessment in 2007 to that in 2011?
Make the answer very short. 1. What is the ratio of the Rating of statistical capacity (0-100) of Overall level in 2007 to that in 2011?
Offer a terse response. 1.04. What is the ratio of the Rating of statistical capacity (0-100) in Periodicity assessment in 2007 to that in 2011?
Make the answer very short. 1.11. What is the ratio of the Rating of statistical capacity (0-100) of Source data assessment in 2007 to that in 2011?
Give a very brief answer. 1. What is the ratio of the Rating of statistical capacity (0-100) in Overall level in 2007 to that in 2012?
Provide a succinct answer. 1.16. What is the ratio of the Rating of statistical capacity (0-100) in Periodicity assessment in 2007 to that in 2012?
Give a very brief answer. 1.11. What is the ratio of the Rating of statistical capacity (0-100) of Source data assessment in 2007 to that in 2012?
Give a very brief answer. 1.5. What is the ratio of the Rating of statistical capacity (0-100) of Overall level in 2007 to that in 2013?
Give a very brief answer. 1.27. What is the ratio of the Rating of statistical capacity (0-100) in Periodicity assessment in 2008 to that in 2009?
Your answer should be compact. 1. What is the ratio of the Rating of statistical capacity (0-100) of Source data assessment in 2008 to that in 2009?
Provide a succinct answer. 1. What is the ratio of the Rating of statistical capacity (0-100) of Source data assessment in 2008 to that in 2010?
Your response must be concise. 1. What is the ratio of the Rating of statistical capacity (0-100) in Overall level in 2008 to that in 2011?
Your response must be concise. 1. What is the ratio of the Rating of statistical capacity (0-100) in Methodology assessment in 2008 to that in 2012?
Offer a very short reply. 1. What is the ratio of the Rating of statistical capacity (0-100) of Overall level in 2008 to that in 2012?
Offer a terse response. 1.12. What is the ratio of the Rating of statistical capacity (0-100) of Periodicity assessment in 2008 to that in 2012?
Your answer should be compact. 1. What is the ratio of the Rating of statistical capacity (0-100) of Source data assessment in 2008 to that in 2012?
Offer a terse response. 1.5. What is the ratio of the Rating of statistical capacity (0-100) of Methodology assessment in 2008 to that in 2013?
Provide a short and direct response. 1.5. What is the ratio of the Rating of statistical capacity (0-100) in Overall level in 2008 to that in 2013?
Keep it short and to the point. 1.22. What is the ratio of the Rating of statistical capacity (0-100) of Periodicity assessment in 2008 to that in 2013?
Ensure brevity in your answer.  0.9. What is the ratio of the Rating of statistical capacity (0-100) of Methodology assessment in 2009 to that in 2010?
Make the answer very short. 1. What is the ratio of the Rating of statistical capacity (0-100) of Methodology assessment in 2009 to that in 2011?
Your answer should be very brief. 1. What is the ratio of the Rating of statistical capacity (0-100) in Overall level in 2009 to that in 2011?
Make the answer very short. 1. What is the ratio of the Rating of statistical capacity (0-100) of Periodicity assessment in 2009 to that in 2011?
Your answer should be compact. 1. What is the ratio of the Rating of statistical capacity (0-100) in Overall level in 2009 to that in 2012?
Make the answer very short. 1.12. What is the ratio of the Rating of statistical capacity (0-100) of Periodicity assessment in 2009 to that in 2012?
Keep it short and to the point. 1. What is the ratio of the Rating of statistical capacity (0-100) of Overall level in 2009 to that in 2013?
Give a very brief answer. 1.22. What is the ratio of the Rating of statistical capacity (0-100) of Periodicity assessment in 2009 to that in 2013?
Keep it short and to the point. 0.9. What is the ratio of the Rating of statistical capacity (0-100) of Source data assessment in 2009 to that in 2013?
Keep it short and to the point. 1.5. What is the ratio of the Rating of statistical capacity (0-100) in Overall level in 2010 to that in 2011?
Offer a terse response. 1. What is the ratio of the Rating of statistical capacity (0-100) in Source data assessment in 2010 to that in 2011?
Offer a very short reply. 1. What is the ratio of the Rating of statistical capacity (0-100) of Overall level in 2010 to that in 2012?
Give a very brief answer. 1.12. What is the ratio of the Rating of statistical capacity (0-100) in Source data assessment in 2010 to that in 2012?
Offer a terse response. 1.5. What is the ratio of the Rating of statistical capacity (0-100) of Overall level in 2010 to that in 2013?
Offer a terse response. 1.22. What is the ratio of the Rating of statistical capacity (0-100) in Periodicity assessment in 2010 to that in 2013?
Give a very brief answer. 0.9. What is the ratio of the Rating of statistical capacity (0-100) of Methodology assessment in 2011 to that in 2012?
Give a very brief answer. 1. What is the ratio of the Rating of statistical capacity (0-100) in Overall level in 2011 to that in 2012?
Ensure brevity in your answer.  1.12. What is the ratio of the Rating of statistical capacity (0-100) in Source data assessment in 2011 to that in 2012?
Your response must be concise. 1.5. What is the ratio of the Rating of statistical capacity (0-100) in Methodology assessment in 2011 to that in 2013?
Your answer should be very brief. 1.5. What is the ratio of the Rating of statistical capacity (0-100) of Overall level in 2011 to that in 2013?
Give a very brief answer. 1.22. What is the ratio of the Rating of statistical capacity (0-100) of Periodicity assessment in 2011 to that in 2013?
Ensure brevity in your answer.  0.9. What is the ratio of the Rating of statistical capacity (0-100) in Methodology assessment in 2012 to that in 2013?
Offer a very short reply. 1.5. What is the ratio of the Rating of statistical capacity (0-100) in Overall level in 2012 to that in 2013?
Make the answer very short. 1.09. What is the ratio of the Rating of statistical capacity (0-100) in Periodicity assessment in 2012 to that in 2013?
Your answer should be very brief. 0.9. What is the difference between the highest and the second highest Rating of statistical capacity (0-100) of Overall level?
Provide a succinct answer. 2.22. What is the difference between the highest and the second highest Rating of statistical capacity (0-100) of Periodicity assessment?
Ensure brevity in your answer.  0. What is the difference between the highest and the second highest Rating of statistical capacity (0-100) of Source data assessment?
Your answer should be very brief. 0. What is the difference between the highest and the lowest Rating of statistical capacity (0-100) of Overall level?
Your answer should be very brief. 13.33. What is the difference between the highest and the lowest Rating of statistical capacity (0-100) of Source data assessment?
Provide a short and direct response. 20. 